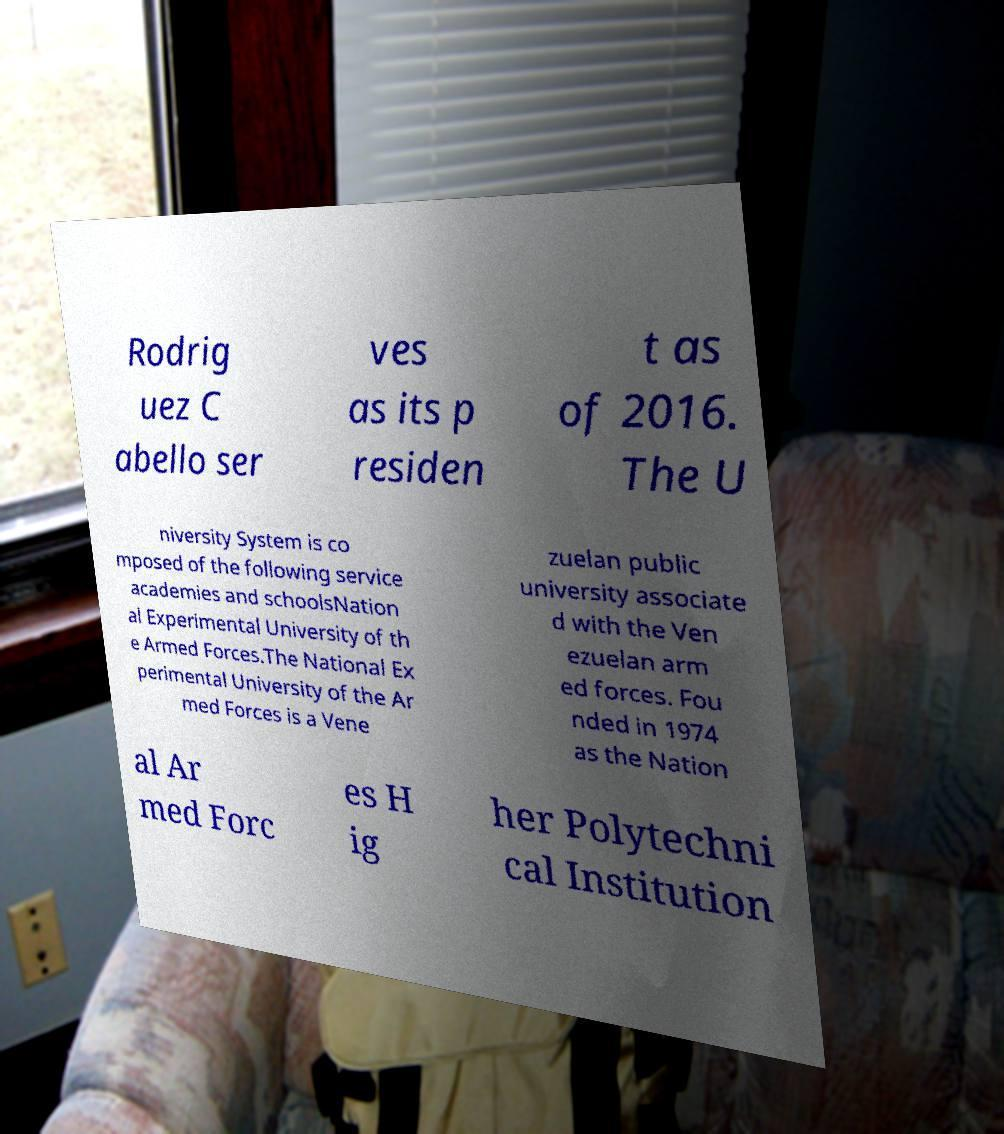What messages or text are displayed in this image? I need them in a readable, typed format. Rodrig uez C abello ser ves as its p residen t as of 2016. The U niversity System is co mposed of the following service academies and schoolsNation al Experimental University of th e Armed Forces.The National Ex perimental University of the Ar med Forces is a Vene zuelan public university associate d with the Ven ezuelan arm ed forces. Fou nded in 1974 as the Nation al Ar med Forc es H ig her Polytechni cal Institution 